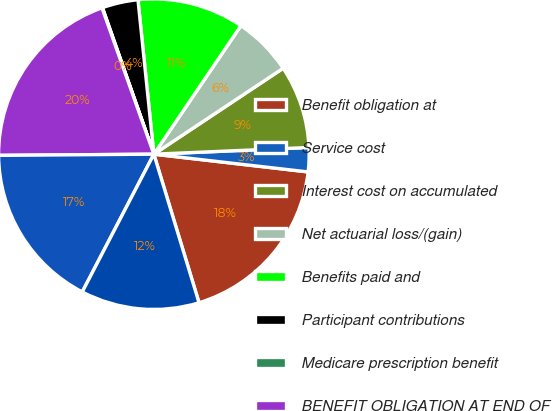Convert chart to OTSL. <chart><loc_0><loc_0><loc_500><loc_500><pie_chart><fcel>Benefit obligation at<fcel>Service cost<fcel>Interest cost on accumulated<fcel>Net actuarial loss/(gain)<fcel>Benefits paid and<fcel>Participant contributions<fcel>Medicare prescription benefit<fcel>BENEFIT OBLIGATION AT END OF<fcel>Fair value of plan assets at<fcel>Actual return on plan assets<nl><fcel>18.48%<fcel>2.51%<fcel>8.65%<fcel>6.19%<fcel>11.11%<fcel>3.74%<fcel>0.05%<fcel>19.7%<fcel>17.25%<fcel>12.33%<nl></chart> 